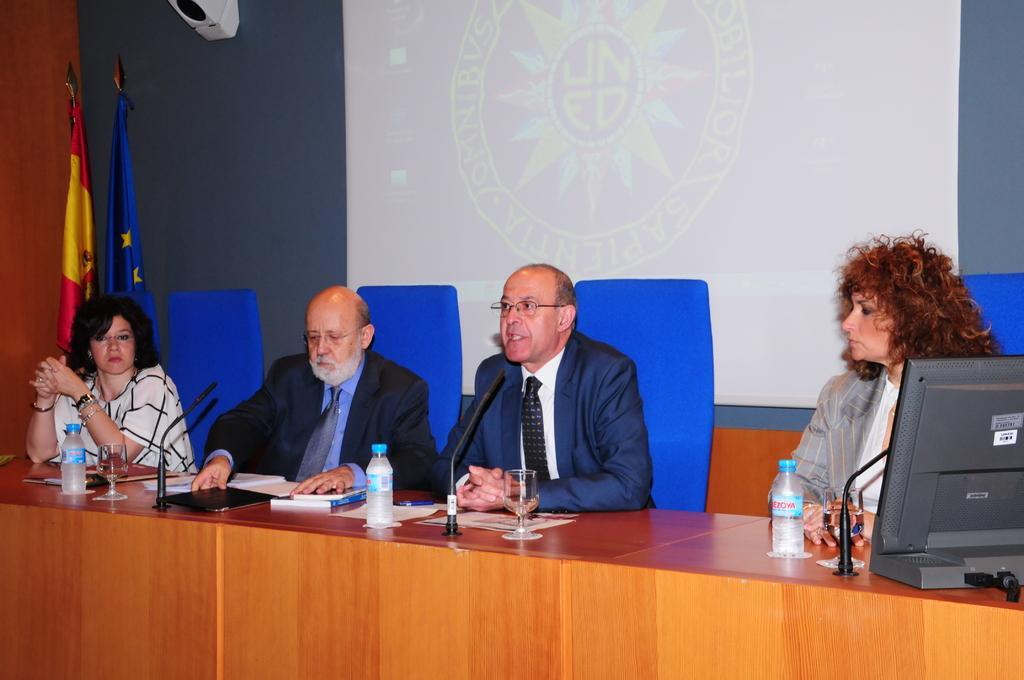Describe this image in one or two sentences. In this picture there are four persons sitting on the chairs in front of a table. On the table there is a bottle,glass, paper, book and mike's. Here we can see a person sitting second from the left wear a suit of blue color and having the spectacles. He is talking on the microphone. Even on the background we can observe a screen and on the left side we can see two flags. 